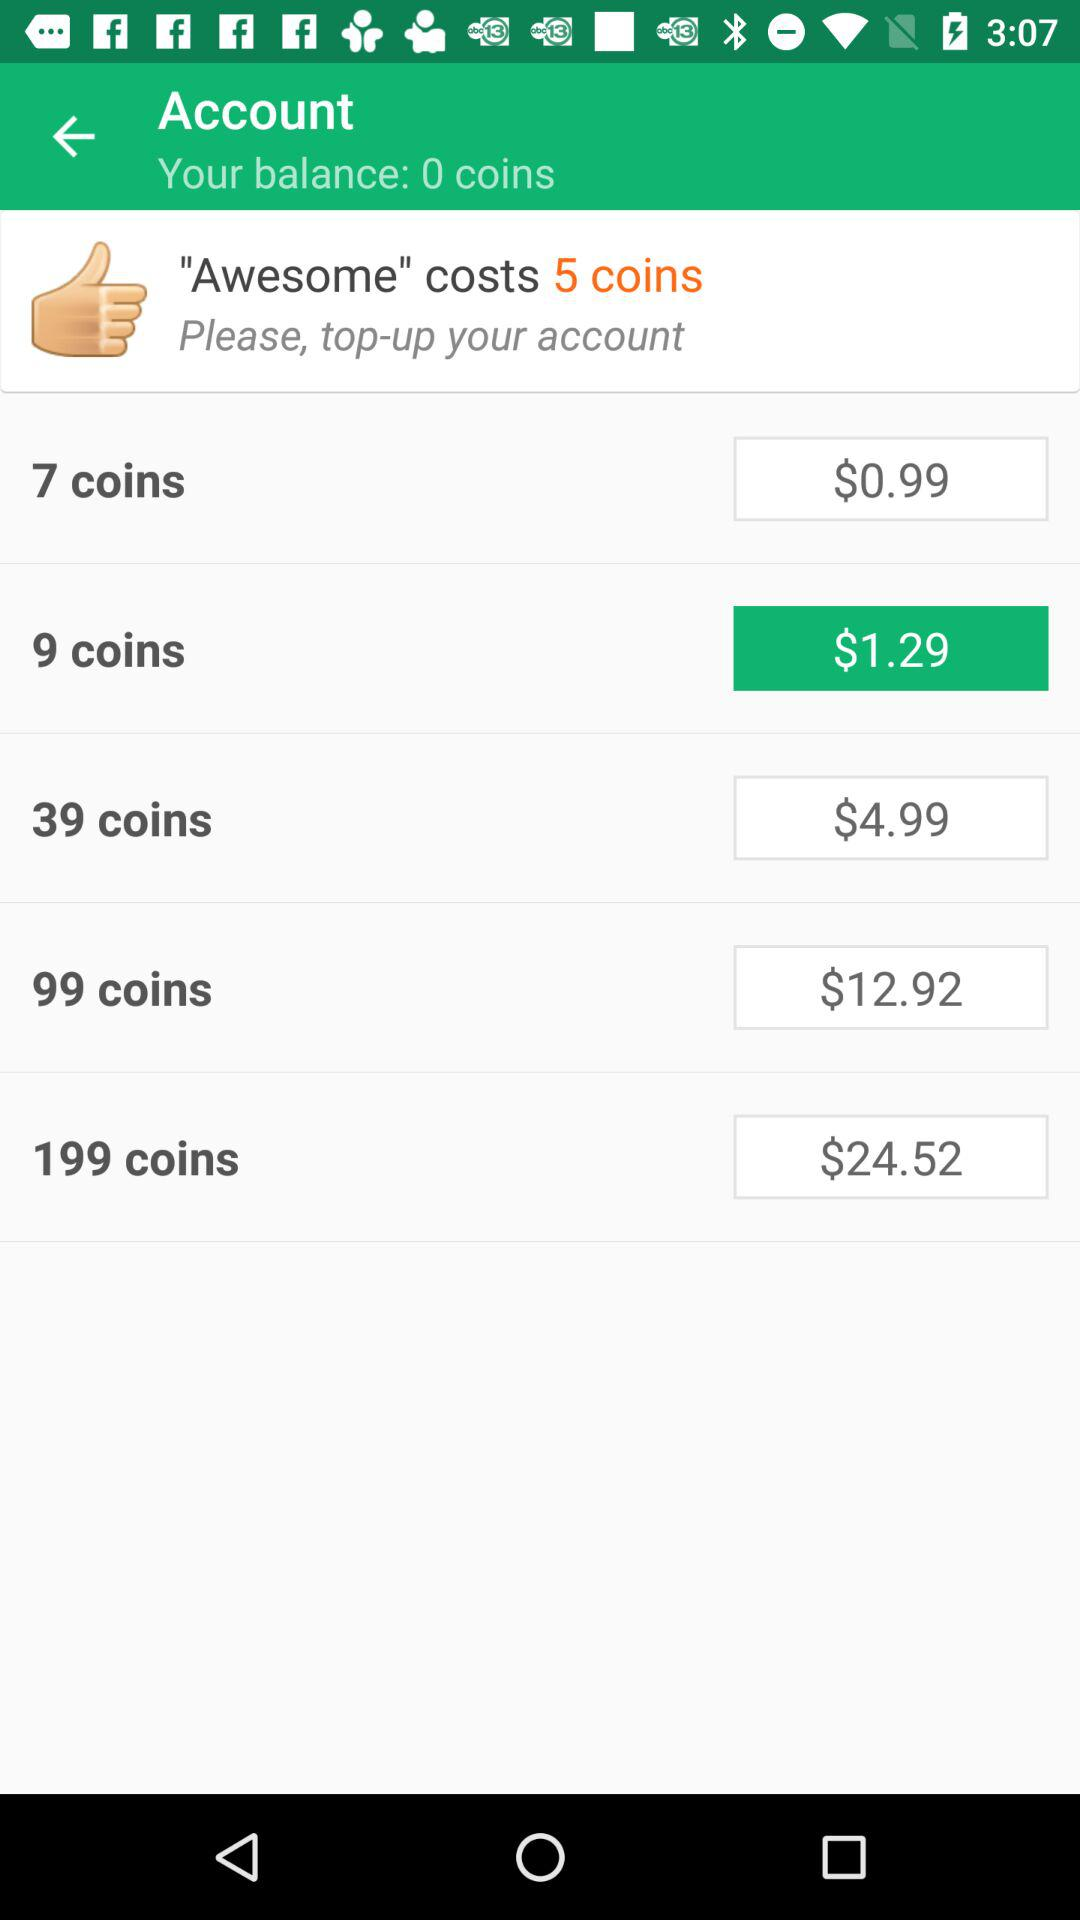What is the account balance? The account balance is 0 coins. 